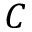<formula> <loc_0><loc_0><loc_500><loc_500>C</formula> 